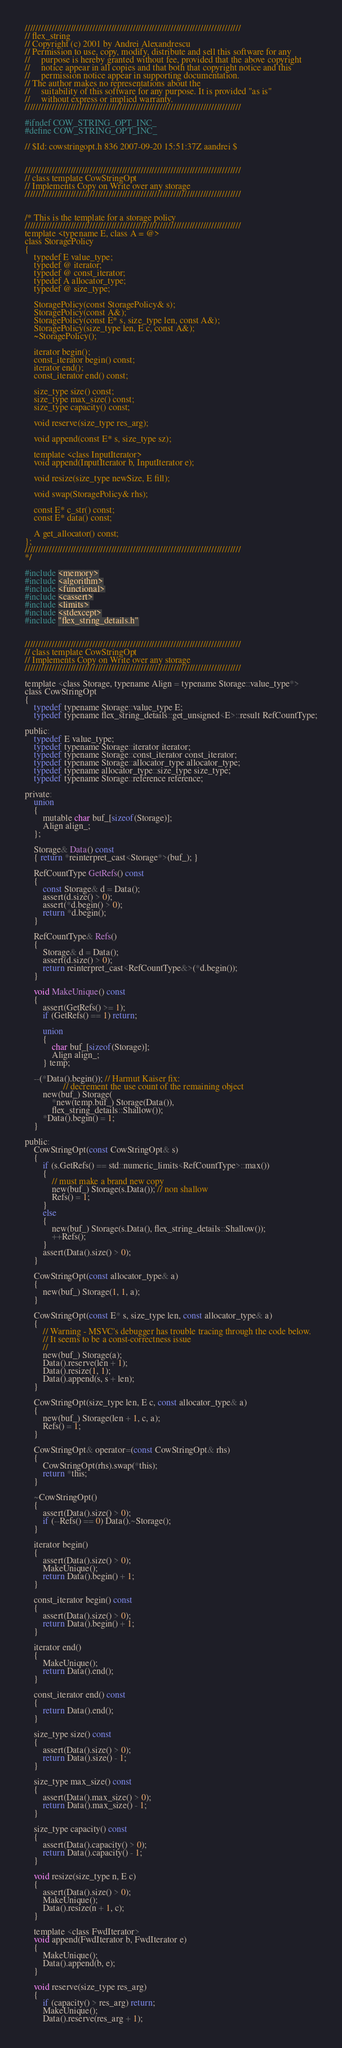Convert code to text. <code><loc_0><loc_0><loc_500><loc_500><_C_>////////////////////////////////////////////////////////////////////////////////
// flex_string
// Copyright (c) 2001 by Andrei Alexandrescu
// Permission to use, copy, modify, distribute and sell this software for any
//     purpose is hereby granted without fee, provided that the above copyright
//     notice appear in all copies and that both that copyright notice and this
//     permission notice appear in supporting documentation.
// The author makes no representations about the
//     suitability of this software for any purpose. It is provided "as is"
//     without express or implied warranty.
////////////////////////////////////////////////////////////////////////////////

#ifndef COW_STRING_OPT_INC_
#define COW_STRING_OPT_INC_

// $Id: cowstringopt.h 836 2007-09-20 15:51:37Z aandrei $


////////////////////////////////////////////////////////////////////////////////
// class template CowStringOpt
// Implements Copy on Write over any storage
////////////////////////////////////////////////////////////////////////////////


/* This is the template for a storage policy
////////////////////////////////////////////////////////////////////////////////
template <typename E, class A = @>
class StoragePolicy
{
    typedef E value_type;
    typedef @ iterator;
    typedef @ const_iterator;
    typedef A allocator_type;
    typedef @ size_type;
    
    StoragePolicy(const StoragePolicy& s);
    StoragePolicy(const A&);
    StoragePolicy(const E* s, size_type len, const A&);
    StoragePolicy(size_type len, E c, const A&);
    ~StoragePolicy();

    iterator begin();
    const_iterator begin() const;
    iterator end();
    const_iterator end() const;
    
    size_type size() const;
    size_type max_size() const;
    size_type capacity() const;

    void reserve(size_type res_arg);

    void append(const E* s, size_type sz);
    
    template <class InputIterator>
    void append(InputIterator b, InputIterator e);

    void resize(size_type newSize, E fill);

    void swap(StoragePolicy& rhs);
    
    const E* c_str() const;
    const E* data() const;
    
    A get_allocator() const;
};
////////////////////////////////////////////////////////////////////////////////
*/

#include <memory>
#include <algorithm>
#include <functional>
#include <cassert>
#include <limits>
#include <stdexcept>
#include "flex_string_details.h"


////////////////////////////////////////////////////////////////////////////////
// class template CowStringOpt
// Implements Copy on Write over any storage
////////////////////////////////////////////////////////////////////////////////

template <class Storage, typename Align = typename Storage::value_type*>
class CowStringOpt
{
    typedef typename Storage::value_type E;
    typedef typename flex_string_details::get_unsigned<E>::result RefCountType;

public:
    typedef E value_type;
    typedef typename Storage::iterator iterator;
    typedef typename Storage::const_iterator const_iterator;
    typedef typename Storage::allocator_type allocator_type;
    typedef typename allocator_type::size_type size_type;
    typedef typename Storage::reference reference;
    
private:
    union
    {
        mutable char buf_[sizeof(Storage)];
        Align align_;
    };

    Storage& Data() const
    { return *reinterpret_cast<Storage*>(buf_); }

    RefCountType GetRefs() const
    {
        const Storage& d = Data();
        assert(d.size() > 0);
        assert(*d.begin() > 0);
        return *d.begin();
    }
    
    RefCountType& Refs()
    {
        Storage& d = Data();
        assert(d.size() > 0);
        return reinterpret_cast<RefCountType&>(*d.begin());
    }
    
    void MakeUnique() const
    {
        assert(GetRefs() >= 1);
        if (GetRefs() == 1) return;

        union
        {
            char buf_[sizeof(Storage)];
            Align align_;
        } temp;

	--(*Data().begin()); // Harmut Kaiser fix:
			     // decrement the use count of the remaining object
        new(buf_) Storage(
            *new(temp.buf_) Storage(Data()), 
            flex_string_details::Shallow());
        *Data().begin() = 1;
    }

public:
    CowStringOpt(const CowStringOpt& s)
    {
        if (s.GetRefs() == std::numeric_limits<RefCountType>::max())
        {
            // must make a brand new copy
            new(buf_) Storage(s.Data()); // non shallow
            Refs() = 1;
        }
        else
        {
            new(buf_) Storage(s.Data(), flex_string_details::Shallow());
            ++Refs();
        }
        assert(Data().size() > 0);
    }
    
    CowStringOpt(const allocator_type& a)
    {
        new(buf_) Storage(1, 1, a);
    }
    
    CowStringOpt(const E* s, size_type len, const allocator_type& a)
    {
        // Warning - MSVC's debugger has trouble tracing through the code below.
        // It seems to be a const-correctness issue
        //
        new(buf_) Storage(a);
        Data().reserve(len + 1);
        Data().resize(1, 1);
        Data().append(s, s + len);
    }

    CowStringOpt(size_type len, E c, const allocator_type& a)
    {
        new(buf_) Storage(len + 1, c, a);
        Refs() = 1;
    }
    
    CowStringOpt& operator=(const CowStringOpt& rhs)
    {
        CowStringOpt(rhs).swap(*this);
        return *this;
    }

    ~CowStringOpt()
    {
        assert(Data().size() > 0);
        if (--Refs() == 0) Data().~Storage();
    }

    iterator begin()
    {
        assert(Data().size() > 0);
        MakeUnique();
        return Data().begin() + 1; 
    }
    
    const_iterator begin() const
    {
        assert(Data().size() > 0);
        return Data().begin() + 1; 
    }
    
    iterator end()
    {
        MakeUnique();
        return Data().end(); 
    }
    
    const_iterator end() const
    {
        return Data().end(); 
    }
    
    size_type size() const
    {
        assert(Data().size() > 0);
        return Data().size() - 1;
    }

    size_type max_size() const
    { 
        assert(Data().max_size() > 0);
        return Data().max_size() - 1;
    }

    size_type capacity() const
    { 
        assert(Data().capacity() > 0);
        return Data().capacity() - 1;
    }

    void resize(size_type n, E c)
    {
        assert(Data().size() > 0);
        MakeUnique();
        Data().resize(n + 1, c);
    }

    template <class FwdIterator>
    void append(FwdIterator b, FwdIterator e)
    {
        MakeUnique();
        Data().append(b, e);
    }
    
    void reserve(size_type res_arg)
    {
        if (capacity() > res_arg) return;
        MakeUnique();
        Data().reserve(res_arg + 1);</code> 